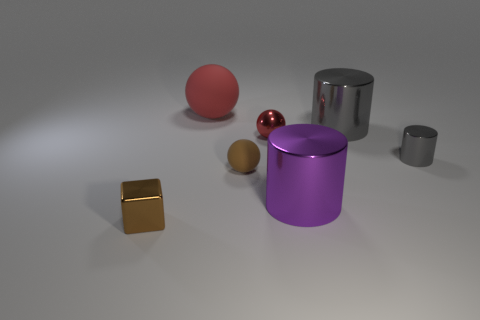What number of other objects are there of the same size as the brown shiny thing?
Your response must be concise. 3. There is a tiny brown thing behind the brown shiny block that is in front of the tiny brown thing that is to the right of the cube; what is its material?
Offer a very short reply. Rubber. How many cubes are either tiny gray shiny things or large matte things?
Make the answer very short. 0. Are there any other things that are the same shape as the purple thing?
Your response must be concise. Yes. Are there more big purple cylinders left of the metal cube than tiny gray shiny things on the left side of the tiny brown rubber ball?
Your answer should be compact. No. How many brown objects are to the right of the rubber ball that is on the left side of the brown ball?
Offer a terse response. 1. How many objects are small brown matte cylinders or tiny metal cylinders?
Offer a terse response. 1. Does the purple thing have the same shape as the small gray metal object?
Give a very brief answer. Yes. What is the big purple object made of?
Keep it short and to the point. Metal. What number of objects are in front of the small shiny ball and behind the brown metallic thing?
Provide a succinct answer. 3. 